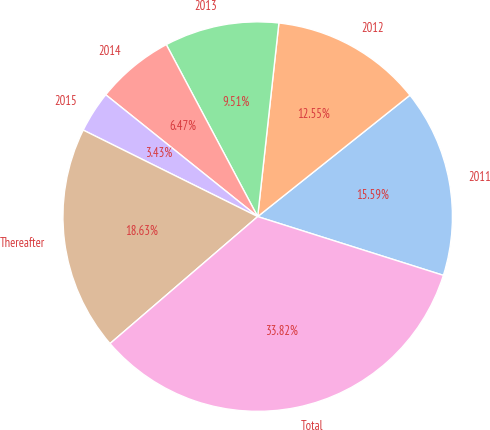Convert chart to OTSL. <chart><loc_0><loc_0><loc_500><loc_500><pie_chart><fcel>2011<fcel>2012<fcel>2013<fcel>2014<fcel>2015<fcel>Thereafter<fcel>Total<nl><fcel>15.59%<fcel>12.55%<fcel>9.51%<fcel>6.47%<fcel>3.43%<fcel>18.63%<fcel>33.82%<nl></chart> 